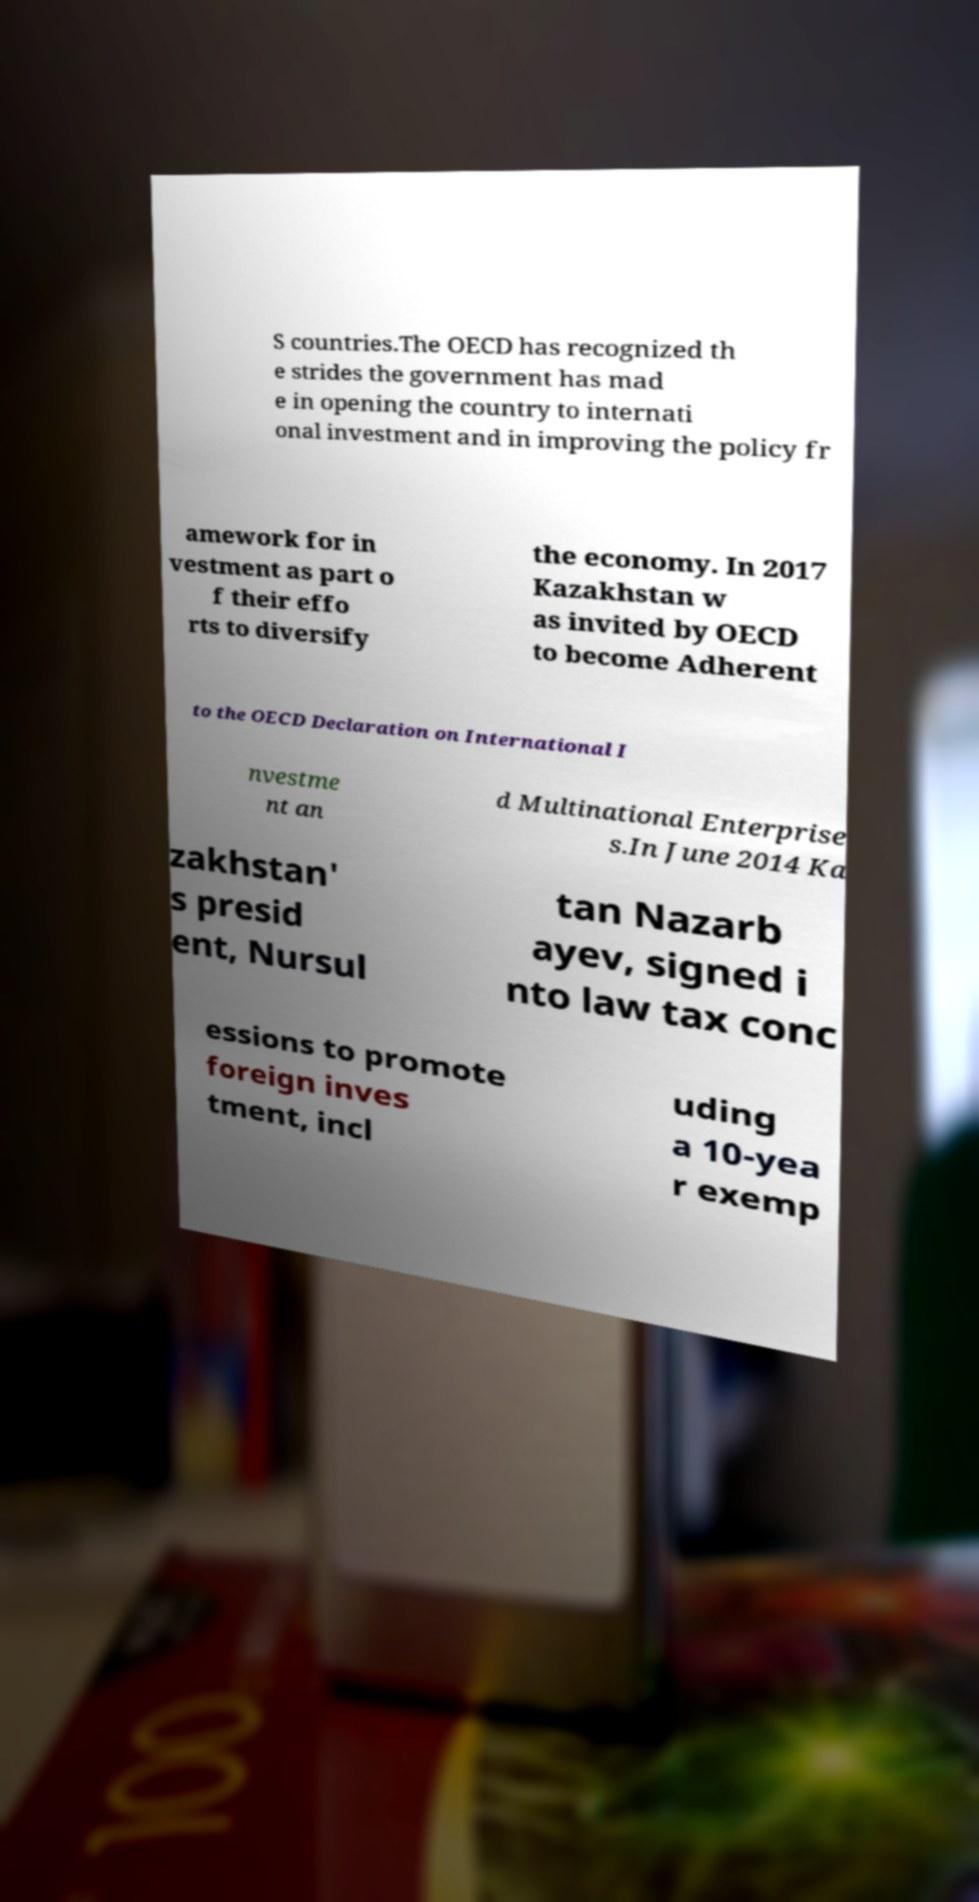Could you assist in decoding the text presented in this image and type it out clearly? S countries.The OECD has recognized th e strides the government has mad e in opening the country to internati onal investment and in improving the policy fr amework for in vestment as part o f their effo rts to diversify the economy. In 2017 Kazakhstan w as invited by OECD to become Adherent to the OECD Declaration on International I nvestme nt an d Multinational Enterprise s.In June 2014 Ka zakhstan' s presid ent, Nursul tan Nazarb ayev, signed i nto law tax conc essions to promote foreign inves tment, incl uding a 10-yea r exemp 